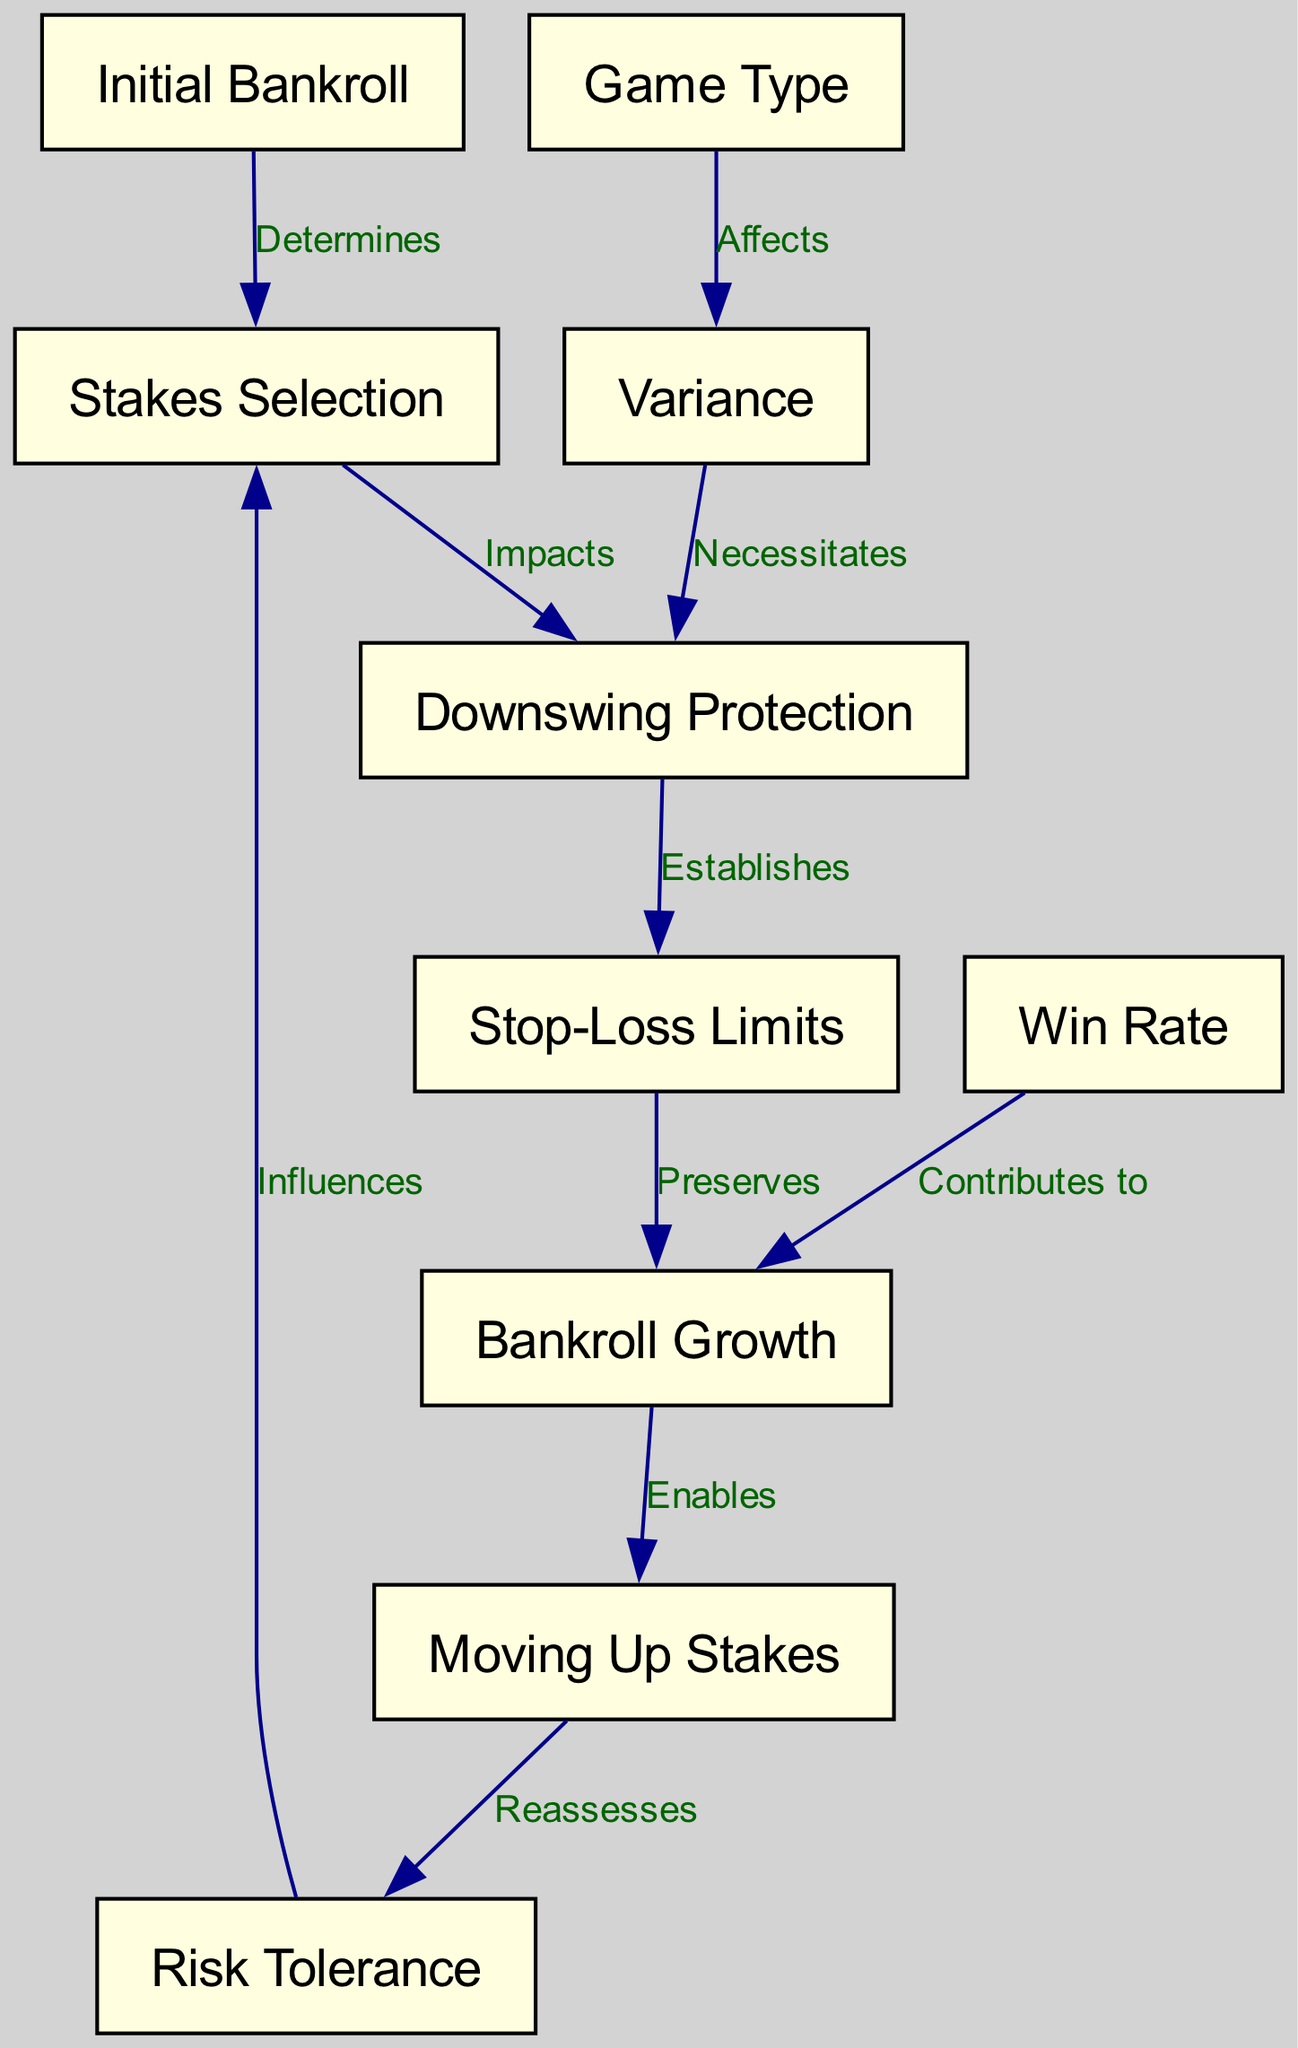What is the starting point of the diagram? The starting point of the diagram is the "Initial Bankroll," which is the first node.
Answer: Initial Bankroll How many nodes are in the diagram? The diagram has a total of 10 nodes, which are each defined in the JSON data under "nodes."
Answer: 10 What type of influence does "Risk Tolerance" have on "Stakes Selection"? "Risk Tolerance" influences "Stakes Selection," as indicated by the edge labeled "Influences."
Answer: Influences Which node is directly affected by "Game Type"? The node directly affected by "Game Type" is "Variance," based on the edge labeled "Affects."
Answer: Variance What does "Bankroll Growth" enable in the diagram? According to the diagram, "Bankroll Growth" enables "Moving Up Stakes," as shown by the edge labeled "Enables."
Answer: Moving Up Stakes What establishes "Stop-Loss Limits"? "Downswing Protection" establishes "Stop-Loss Limits," as indicated by the edge label "Establishes."
Answer: Downswing Protection How does "Win Rate" contribute to the bankroll management system? "Win Rate" contributes to "Bankroll Growth," which shows how success in poker affects overall bankroll health.
Answer: Bankroll Growth Which factors are involved in the flow from "Downswing Protection" to "Bankroll Growth"? The factors involved in this flow are "Stop-Loss Limits," which preserves "Bankroll Growth," ultimately ensuring stability in the system.
Answer: Stop-Loss Limits What necessitates "Downswing Protection"? "Variance" necessitates "Downswing Protection," highlighting the need for safeguards against the natural ups and downs of poker play.
Answer: Variance What is the relationship between "Moving Up Stakes" and "Risk Tolerance"? "Moving Up Stakes" reassesses "Risk Tolerance," indicating a feedback loop that affects how much risk can be tolerated as bankroll increases.
Answer: Reassesses 